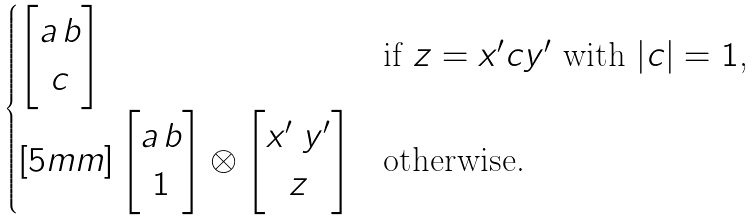<formula> <loc_0><loc_0><loc_500><loc_500>\begin{cases} \begin{bmatrix} a \, b \\ c \end{bmatrix} & \text {if $z = x^{\prime}cy^{\prime}$ with $|c| = 1$,} \\ [ 5 m m ] \begin{bmatrix} a \, b \\ 1 \end{bmatrix} \otimes \begin{bmatrix} x ^ { \prime } \ y ^ { \prime } \\ z \end{bmatrix} & \text {otherwise.} \end{cases}</formula> 